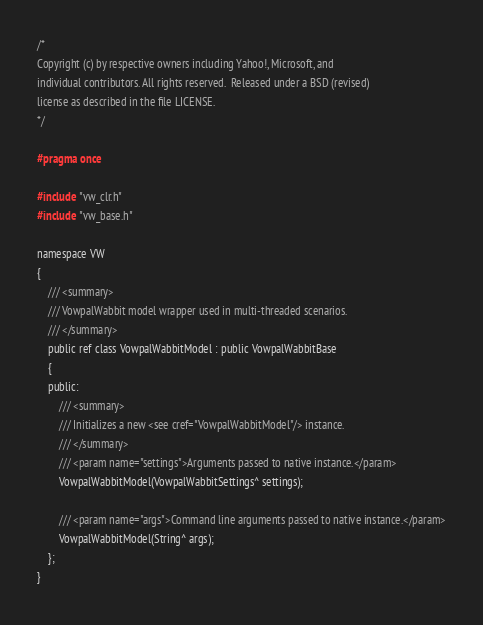<code> <loc_0><loc_0><loc_500><loc_500><_C_>/*
Copyright (c) by respective owners including Yahoo!, Microsoft, and
individual contributors. All rights reserved.  Released under a BSD (revised)
license as described in the file LICENSE.
*/

#pragma once

#include "vw_clr.h"
#include "vw_base.h"

namespace VW
{
    /// <summary>
    /// VowpalWabbit model wrapper used in multi-threaded scenarios.
    /// </summary>
    public ref class VowpalWabbitModel : public VowpalWabbitBase
    {
    public:
        /// <summary>
        /// Initializes a new <see cref="VowpalWabbitModel"/> instance.
        /// </summary>
        /// <param name="settings">Arguments passed to native instance.</param>
        VowpalWabbitModel(VowpalWabbitSettings^ settings);

        /// <param name="args">Command line arguments passed to native instance.</param>
        VowpalWabbitModel(String^ args);
    };
}
</code> 